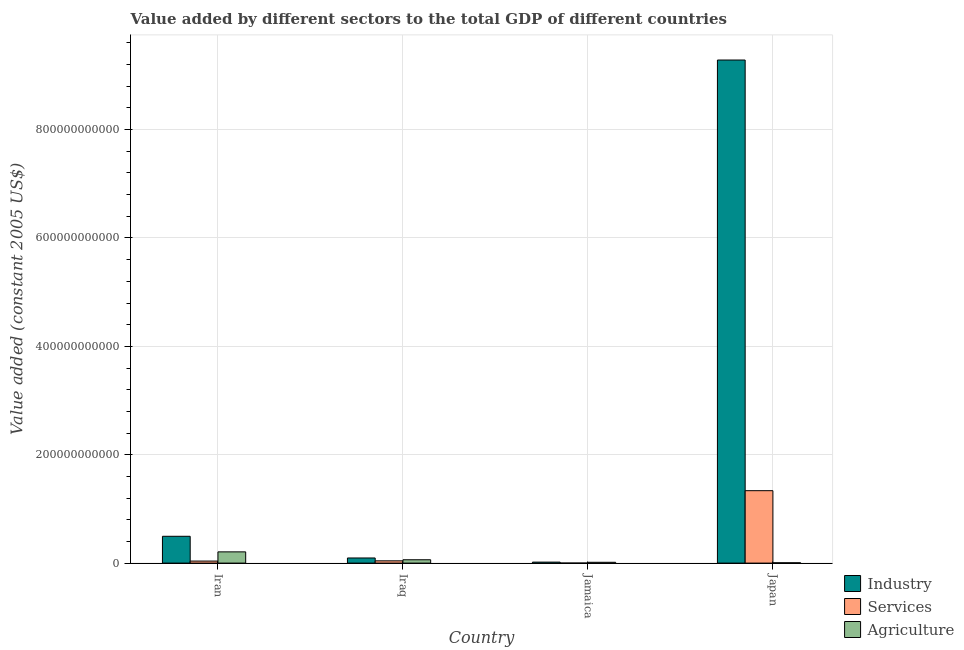How many groups of bars are there?
Offer a very short reply. 4. Are the number of bars per tick equal to the number of legend labels?
Offer a very short reply. Yes. Are the number of bars on each tick of the X-axis equal?
Ensure brevity in your answer.  Yes. In how many cases, is the number of bars for a given country not equal to the number of legend labels?
Provide a succinct answer. 0. What is the value added by agricultural sector in Iran?
Your answer should be very brief. 2.07e+1. Across all countries, what is the maximum value added by agricultural sector?
Ensure brevity in your answer.  2.07e+1. Across all countries, what is the minimum value added by industrial sector?
Offer a very short reply. 1.81e+09. In which country was the value added by agricultural sector minimum?
Your response must be concise. Japan. What is the total value added by industrial sector in the graph?
Your answer should be compact. 9.89e+11. What is the difference between the value added by industrial sector in Jamaica and that in Japan?
Ensure brevity in your answer.  -9.27e+11. What is the difference between the value added by services in Iraq and the value added by industrial sector in Jamaica?
Ensure brevity in your answer.  2.38e+09. What is the average value added by services per country?
Keep it short and to the point. 3.54e+1. What is the difference between the value added by services and value added by industrial sector in Iraq?
Your response must be concise. -5.26e+09. In how many countries, is the value added by services greater than 360000000000 US$?
Your answer should be very brief. 0. What is the ratio of the value added by industrial sector in Iran to that in Iraq?
Ensure brevity in your answer.  5.24. Is the difference between the value added by agricultural sector in Jamaica and Japan greater than the difference between the value added by services in Jamaica and Japan?
Provide a short and direct response. Yes. What is the difference between the highest and the second highest value added by agricultural sector?
Your response must be concise. 1.46e+1. What is the difference between the highest and the lowest value added by industrial sector?
Ensure brevity in your answer.  9.27e+11. In how many countries, is the value added by services greater than the average value added by services taken over all countries?
Give a very brief answer. 1. What does the 3rd bar from the left in Iran represents?
Offer a very short reply. Agriculture. What does the 1st bar from the right in Jamaica represents?
Ensure brevity in your answer.  Agriculture. Are all the bars in the graph horizontal?
Offer a very short reply. No. How many countries are there in the graph?
Keep it short and to the point. 4. What is the difference between two consecutive major ticks on the Y-axis?
Make the answer very short. 2.00e+11. Does the graph contain any zero values?
Keep it short and to the point. No. How many legend labels are there?
Your answer should be compact. 3. What is the title of the graph?
Your answer should be compact. Value added by different sectors to the total GDP of different countries. Does "Consumption Tax" appear as one of the legend labels in the graph?
Your response must be concise. No. What is the label or title of the X-axis?
Provide a succinct answer. Country. What is the label or title of the Y-axis?
Provide a succinct answer. Value added (constant 2005 US$). What is the Value added (constant 2005 US$) of Industry in Iran?
Provide a succinct answer. 4.95e+1. What is the Value added (constant 2005 US$) in Services in Iran?
Your answer should be compact. 3.75e+09. What is the Value added (constant 2005 US$) in Agriculture in Iran?
Provide a succinct answer. 2.07e+1. What is the Value added (constant 2005 US$) in Industry in Iraq?
Provide a short and direct response. 9.44e+09. What is the Value added (constant 2005 US$) in Services in Iraq?
Your answer should be very brief. 4.19e+09. What is the Value added (constant 2005 US$) in Agriculture in Iraq?
Provide a short and direct response. 6.17e+09. What is the Value added (constant 2005 US$) of Industry in Jamaica?
Keep it short and to the point. 1.81e+09. What is the Value added (constant 2005 US$) of Services in Jamaica?
Your response must be concise. 2.63e+07. What is the Value added (constant 2005 US$) in Agriculture in Jamaica?
Give a very brief answer. 1.50e+09. What is the Value added (constant 2005 US$) in Industry in Japan?
Provide a succinct answer. 9.28e+11. What is the Value added (constant 2005 US$) in Services in Japan?
Your answer should be very brief. 1.34e+11. What is the Value added (constant 2005 US$) in Agriculture in Japan?
Keep it short and to the point. 5.95e+08. Across all countries, what is the maximum Value added (constant 2005 US$) in Industry?
Your answer should be very brief. 9.28e+11. Across all countries, what is the maximum Value added (constant 2005 US$) in Services?
Your answer should be compact. 1.34e+11. Across all countries, what is the maximum Value added (constant 2005 US$) of Agriculture?
Give a very brief answer. 2.07e+1. Across all countries, what is the minimum Value added (constant 2005 US$) in Industry?
Keep it short and to the point. 1.81e+09. Across all countries, what is the minimum Value added (constant 2005 US$) in Services?
Offer a very short reply. 2.63e+07. Across all countries, what is the minimum Value added (constant 2005 US$) of Agriculture?
Make the answer very short. 5.95e+08. What is the total Value added (constant 2005 US$) of Industry in the graph?
Make the answer very short. 9.89e+11. What is the total Value added (constant 2005 US$) of Services in the graph?
Your response must be concise. 1.42e+11. What is the total Value added (constant 2005 US$) in Agriculture in the graph?
Your answer should be compact. 2.90e+1. What is the difference between the Value added (constant 2005 US$) of Industry in Iran and that in Iraq?
Your answer should be very brief. 4.00e+1. What is the difference between the Value added (constant 2005 US$) of Services in Iran and that in Iraq?
Give a very brief answer. -4.37e+08. What is the difference between the Value added (constant 2005 US$) in Agriculture in Iran and that in Iraq?
Your answer should be very brief. 1.46e+1. What is the difference between the Value added (constant 2005 US$) of Industry in Iran and that in Jamaica?
Your answer should be very brief. 4.77e+1. What is the difference between the Value added (constant 2005 US$) in Services in Iran and that in Jamaica?
Offer a terse response. 3.72e+09. What is the difference between the Value added (constant 2005 US$) of Agriculture in Iran and that in Jamaica?
Your answer should be compact. 1.92e+1. What is the difference between the Value added (constant 2005 US$) in Industry in Iran and that in Japan?
Provide a succinct answer. -8.79e+11. What is the difference between the Value added (constant 2005 US$) of Services in Iran and that in Japan?
Ensure brevity in your answer.  -1.30e+11. What is the difference between the Value added (constant 2005 US$) of Agriculture in Iran and that in Japan?
Keep it short and to the point. 2.01e+1. What is the difference between the Value added (constant 2005 US$) of Industry in Iraq and that in Jamaica?
Your answer should be very brief. 7.64e+09. What is the difference between the Value added (constant 2005 US$) of Services in Iraq and that in Jamaica?
Make the answer very short. 4.16e+09. What is the difference between the Value added (constant 2005 US$) of Agriculture in Iraq and that in Jamaica?
Provide a short and direct response. 4.66e+09. What is the difference between the Value added (constant 2005 US$) in Industry in Iraq and that in Japan?
Your answer should be compact. -9.19e+11. What is the difference between the Value added (constant 2005 US$) of Services in Iraq and that in Japan?
Offer a terse response. -1.29e+11. What is the difference between the Value added (constant 2005 US$) of Agriculture in Iraq and that in Japan?
Your response must be concise. 5.57e+09. What is the difference between the Value added (constant 2005 US$) of Industry in Jamaica and that in Japan?
Provide a succinct answer. -9.27e+11. What is the difference between the Value added (constant 2005 US$) of Services in Jamaica and that in Japan?
Your response must be concise. -1.34e+11. What is the difference between the Value added (constant 2005 US$) in Agriculture in Jamaica and that in Japan?
Your answer should be very brief. 9.07e+08. What is the difference between the Value added (constant 2005 US$) of Industry in Iran and the Value added (constant 2005 US$) of Services in Iraq?
Provide a succinct answer. 4.53e+1. What is the difference between the Value added (constant 2005 US$) of Industry in Iran and the Value added (constant 2005 US$) of Agriculture in Iraq?
Keep it short and to the point. 4.33e+1. What is the difference between the Value added (constant 2005 US$) in Services in Iran and the Value added (constant 2005 US$) in Agriculture in Iraq?
Your answer should be compact. -2.42e+09. What is the difference between the Value added (constant 2005 US$) in Industry in Iran and the Value added (constant 2005 US$) in Services in Jamaica?
Ensure brevity in your answer.  4.95e+1. What is the difference between the Value added (constant 2005 US$) in Industry in Iran and the Value added (constant 2005 US$) in Agriculture in Jamaica?
Give a very brief answer. 4.80e+1. What is the difference between the Value added (constant 2005 US$) in Services in Iran and the Value added (constant 2005 US$) in Agriculture in Jamaica?
Provide a short and direct response. 2.25e+09. What is the difference between the Value added (constant 2005 US$) of Industry in Iran and the Value added (constant 2005 US$) of Services in Japan?
Keep it short and to the point. -8.42e+1. What is the difference between the Value added (constant 2005 US$) in Industry in Iran and the Value added (constant 2005 US$) in Agriculture in Japan?
Your answer should be compact. 4.89e+1. What is the difference between the Value added (constant 2005 US$) of Services in Iran and the Value added (constant 2005 US$) of Agriculture in Japan?
Provide a short and direct response. 3.15e+09. What is the difference between the Value added (constant 2005 US$) of Industry in Iraq and the Value added (constant 2005 US$) of Services in Jamaica?
Your response must be concise. 9.42e+09. What is the difference between the Value added (constant 2005 US$) in Industry in Iraq and the Value added (constant 2005 US$) in Agriculture in Jamaica?
Ensure brevity in your answer.  7.94e+09. What is the difference between the Value added (constant 2005 US$) of Services in Iraq and the Value added (constant 2005 US$) of Agriculture in Jamaica?
Offer a very short reply. 2.69e+09. What is the difference between the Value added (constant 2005 US$) in Industry in Iraq and the Value added (constant 2005 US$) in Services in Japan?
Offer a very short reply. -1.24e+11. What is the difference between the Value added (constant 2005 US$) in Industry in Iraq and the Value added (constant 2005 US$) in Agriculture in Japan?
Your response must be concise. 8.85e+09. What is the difference between the Value added (constant 2005 US$) of Services in Iraq and the Value added (constant 2005 US$) of Agriculture in Japan?
Ensure brevity in your answer.  3.59e+09. What is the difference between the Value added (constant 2005 US$) of Industry in Jamaica and the Value added (constant 2005 US$) of Services in Japan?
Offer a very short reply. -1.32e+11. What is the difference between the Value added (constant 2005 US$) in Industry in Jamaica and the Value added (constant 2005 US$) in Agriculture in Japan?
Your answer should be compact. 1.21e+09. What is the difference between the Value added (constant 2005 US$) in Services in Jamaica and the Value added (constant 2005 US$) in Agriculture in Japan?
Make the answer very short. -5.69e+08. What is the average Value added (constant 2005 US$) in Industry per country?
Offer a terse response. 2.47e+11. What is the average Value added (constant 2005 US$) in Services per country?
Give a very brief answer. 3.54e+1. What is the average Value added (constant 2005 US$) in Agriculture per country?
Your answer should be very brief. 7.25e+09. What is the difference between the Value added (constant 2005 US$) in Industry and Value added (constant 2005 US$) in Services in Iran?
Offer a terse response. 4.57e+1. What is the difference between the Value added (constant 2005 US$) in Industry and Value added (constant 2005 US$) in Agriculture in Iran?
Offer a terse response. 2.88e+1. What is the difference between the Value added (constant 2005 US$) of Services and Value added (constant 2005 US$) of Agriculture in Iran?
Your answer should be very brief. -1.70e+1. What is the difference between the Value added (constant 2005 US$) in Industry and Value added (constant 2005 US$) in Services in Iraq?
Provide a succinct answer. 5.26e+09. What is the difference between the Value added (constant 2005 US$) in Industry and Value added (constant 2005 US$) in Agriculture in Iraq?
Your response must be concise. 3.28e+09. What is the difference between the Value added (constant 2005 US$) in Services and Value added (constant 2005 US$) in Agriculture in Iraq?
Provide a short and direct response. -1.98e+09. What is the difference between the Value added (constant 2005 US$) in Industry and Value added (constant 2005 US$) in Services in Jamaica?
Keep it short and to the point. 1.78e+09. What is the difference between the Value added (constant 2005 US$) of Industry and Value added (constant 2005 US$) of Agriculture in Jamaica?
Keep it short and to the point. 3.03e+08. What is the difference between the Value added (constant 2005 US$) in Services and Value added (constant 2005 US$) in Agriculture in Jamaica?
Offer a very short reply. -1.48e+09. What is the difference between the Value added (constant 2005 US$) of Industry and Value added (constant 2005 US$) of Services in Japan?
Keep it short and to the point. 7.95e+11. What is the difference between the Value added (constant 2005 US$) in Industry and Value added (constant 2005 US$) in Agriculture in Japan?
Your answer should be very brief. 9.28e+11. What is the difference between the Value added (constant 2005 US$) in Services and Value added (constant 2005 US$) in Agriculture in Japan?
Give a very brief answer. 1.33e+11. What is the ratio of the Value added (constant 2005 US$) of Industry in Iran to that in Iraq?
Keep it short and to the point. 5.24. What is the ratio of the Value added (constant 2005 US$) of Services in Iran to that in Iraq?
Give a very brief answer. 0.9. What is the ratio of the Value added (constant 2005 US$) of Agriculture in Iran to that in Iraq?
Your answer should be compact. 3.36. What is the ratio of the Value added (constant 2005 US$) of Industry in Iran to that in Jamaica?
Offer a terse response. 27.41. What is the ratio of the Value added (constant 2005 US$) in Services in Iran to that in Jamaica?
Keep it short and to the point. 142.78. What is the ratio of the Value added (constant 2005 US$) of Agriculture in Iran to that in Jamaica?
Keep it short and to the point. 13.8. What is the ratio of the Value added (constant 2005 US$) of Industry in Iran to that in Japan?
Your answer should be compact. 0.05. What is the ratio of the Value added (constant 2005 US$) in Services in Iran to that in Japan?
Your answer should be very brief. 0.03. What is the ratio of the Value added (constant 2005 US$) of Agriculture in Iran to that in Japan?
Your answer should be compact. 34.83. What is the ratio of the Value added (constant 2005 US$) in Industry in Iraq to that in Jamaica?
Your answer should be very brief. 5.23. What is the ratio of the Value added (constant 2005 US$) of Services in Iraq to that in Jamaica?
Your answer should be compact. 159.43. What is the ratio of the Value added (constant 2005 US$) in Agriculture in Iraq to that in Jamaica?
Make the answer very short. 4.11. What is the ratio of the Value added (constant 2005 US$) in Industry in Iraq to that in Japan?
Ensure brevity in your answer.  0.01. What is the ratio of the Value added (constant 2005 US$) in Services in Iraq to that in Japan?
Provide a succinct answer. 0.03. What is the ratio of the Value added (constant 2005 US$) of Agriculture in Iraq to that in Japan?
Offer a very short reply. 10.36. What is the ratio of the Value added (constant 2005 US$) of Industry in Jamaica to that in Japan?
Keep it short and to the point. 0. What is the ratio of the Value added (constant 2005 US$) of Services in Jamaica to that in Japan?
Make the answer very short. 0. What is the ratio of the Value added (constant 2005 US$) in Agriculture in Jamaica to that in Japan?
Offer a very short reply. 2.52. What is the difference between the highest and the second highest Value added (constant 2005 US$) of Industry?
Provide a succinct answer. 8.79e+11. What is the difference between the highest and the second highest Value added (constant 2005 US$) in Services?
Keep it short and to the point. 1.29e+11. What is the difference between the highest and the second highest Value added (constant 2005 US$) of Agriculture?
Your response must be concise. 1.46e+1. What is the difference between the highest and the lowest Value added (constant 2005 US$) in Industry?
Keep it short and to the point. 9.27e+11. What is the difference between the highest and the lowest Value added (constant 2005 US$) of Services?
Your answer should be compact. 1.34e+11. What is the difference between the highest and the lowest Value added (constant 2005 US$) in Agriculture?
Give a very brief answer. 2.01e+1. 